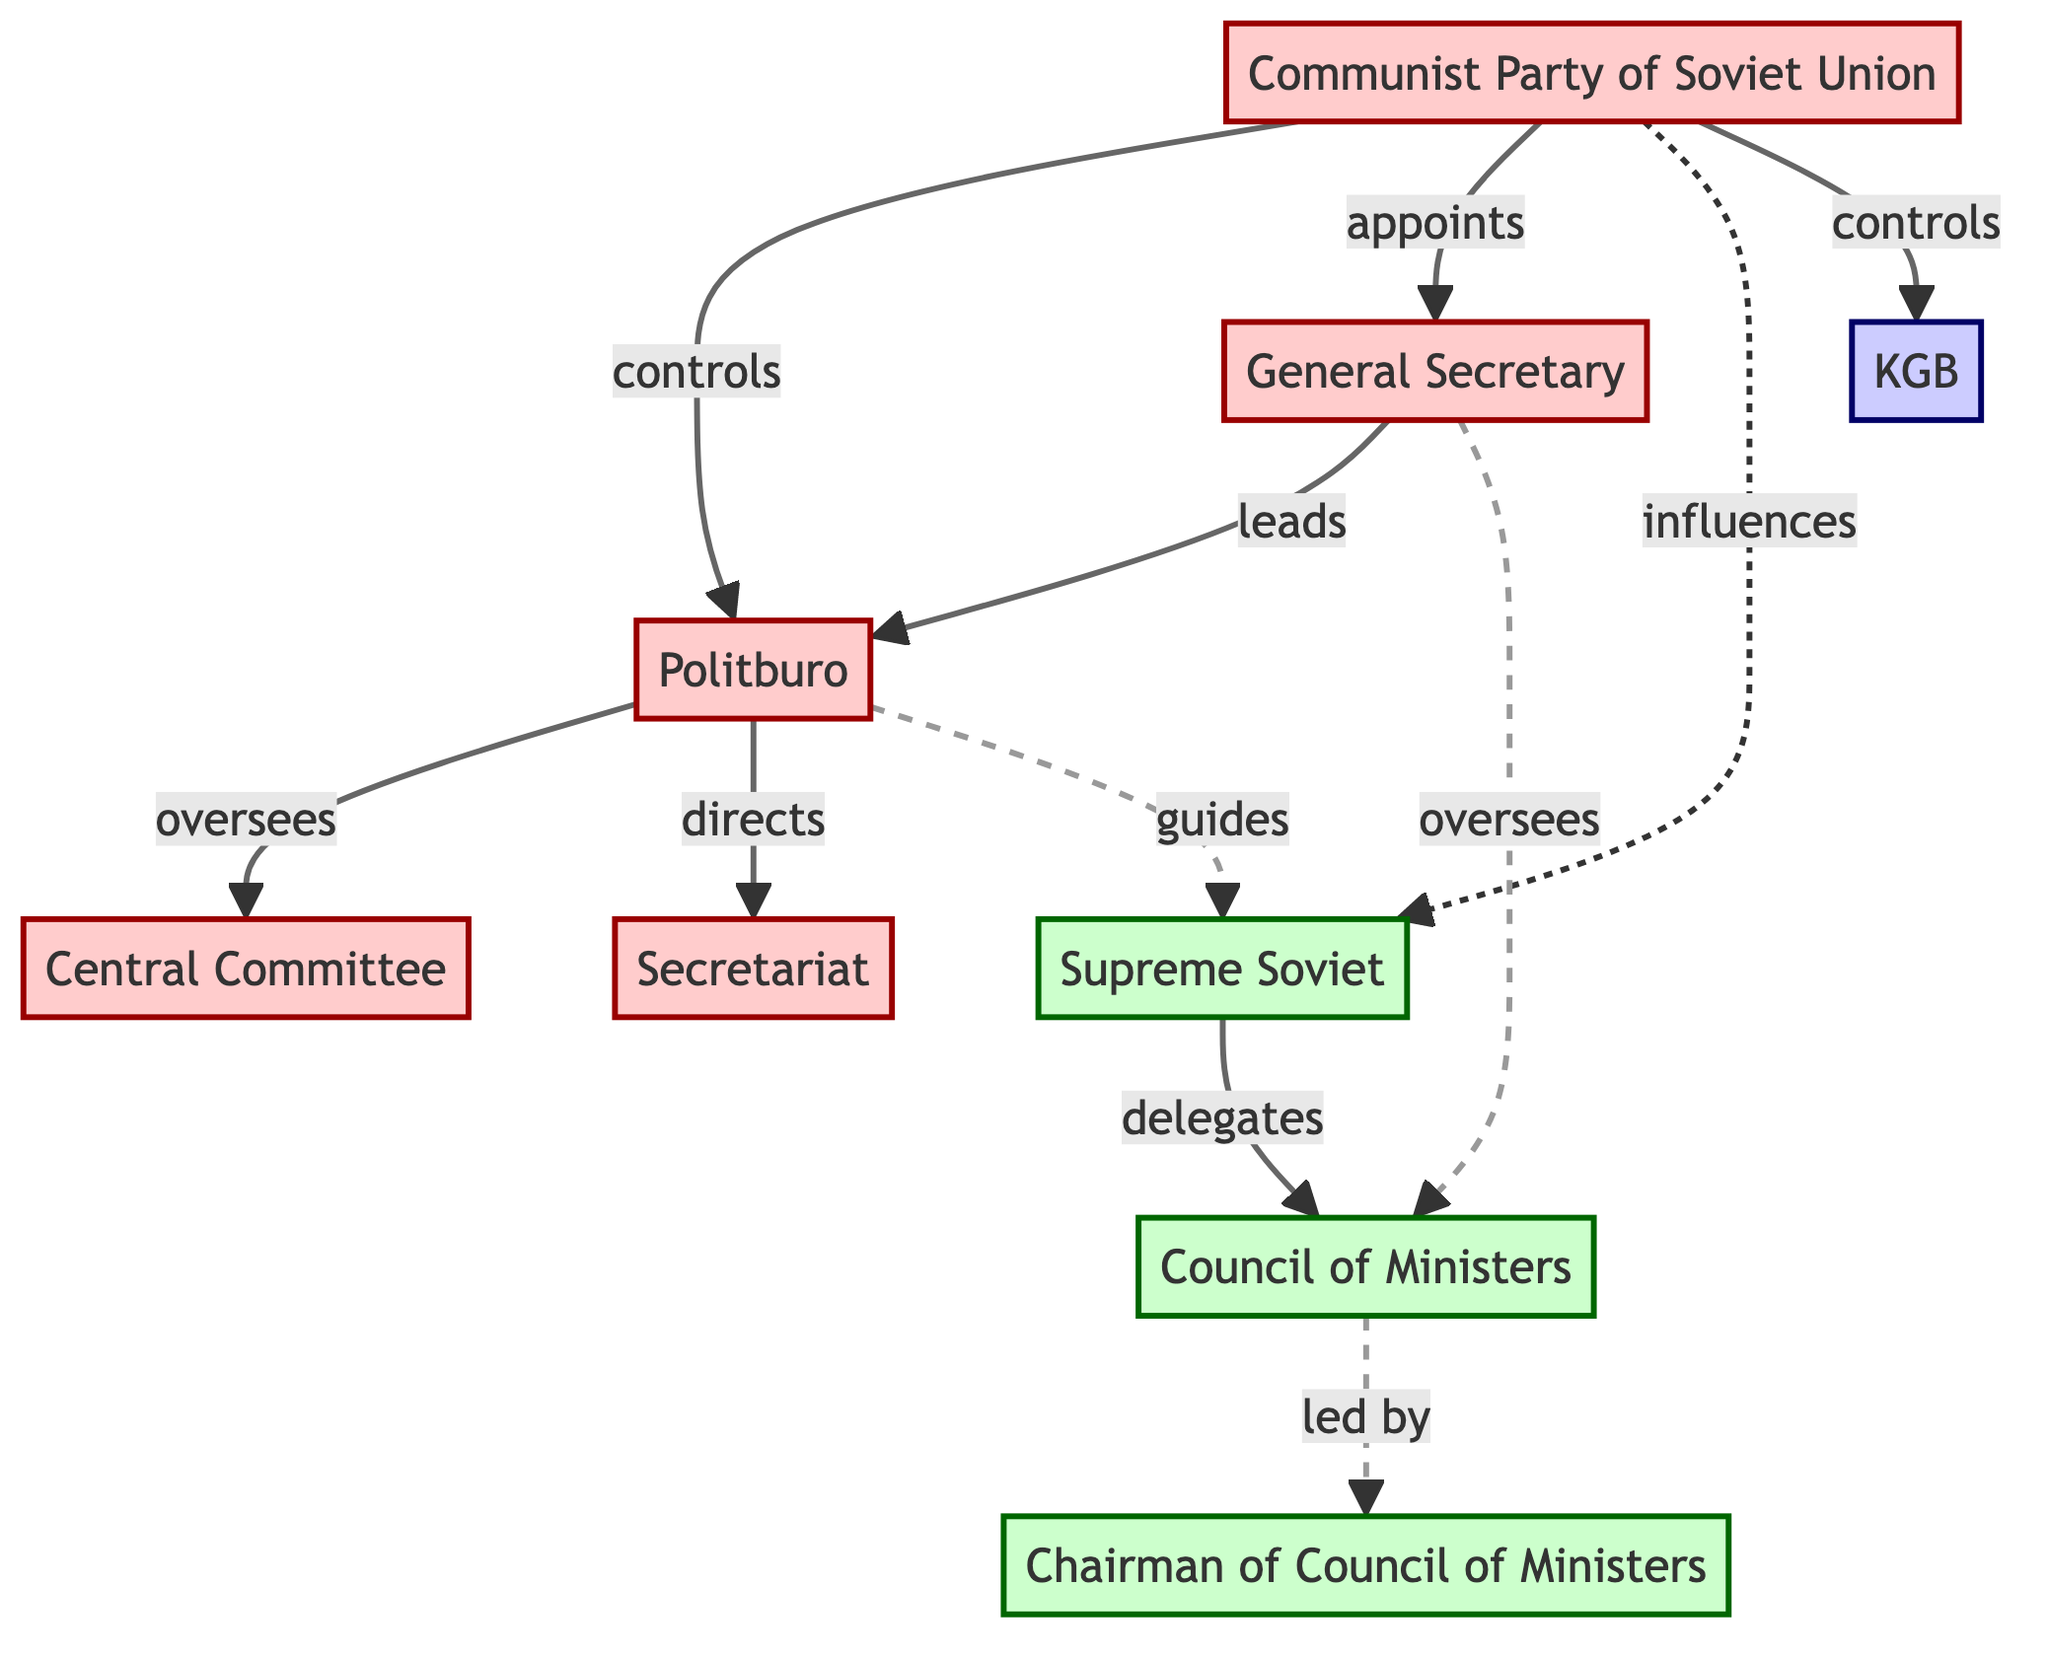What is the top governing body in the diagram? The top governing body is represented by the node labeled "Communist Party of Soviet Union," which is at the highest level in the hierarchy.
Answer: Communist Party of Soviet Union How many main bodies are represented in the diagram? By counting the distinct nodes in the diagram, there are a total of 9 main bodies depicted.
Answer: 9 Which body is directly overseen by the Politburo? The Politburo directly oversees the "Central Committee," as indicated by the flow from the Politburo node to the Central Committee node.
Answer: Central Committee Who leads the Politburo? The "General Secretary" leads the Politburo, as shown by the directed flow from the General Secretary node to the Politburo node.
Answer: General Secretary What is the relationship between the Communist Party of the Soviet Union and the KGB? The diagram indicates a direct control relationship where the Communist Party of the Soviet Union controls the KGB.
Answer: controls What body is influenced by both the Communist Party and the Politburo? The "Supreme Soviet" is influenced by both the Communist Party of the Soviet Union and the Politburo, as shown by the dashed lines connecting these nodes to the Supreme Soviet.
Answer: Supreme Soviet How is the Council of Ministers structured in relation to the Supreme Soviet? The Council of Ministers is delegate-led by the Supreme Soviet, indicating that the Supreme Soviet has authority over the Council of Ministers.
Answer: delegates Which position is responsible for leading the Council of Ministers? The "Chairman of Council of Ministers" is responsible for leading the Council of Ministers, as indicated by the connection from the Council of Ministers node to the Chairman node.
Answer: Chairman of Council of Ministers What type of relationship does the General Secretary have with the Council of Ministers? The General Secretary oversees the Council of Ministers, as indicated by the dotted line representing an oversight relationship.
Answer: oversees 